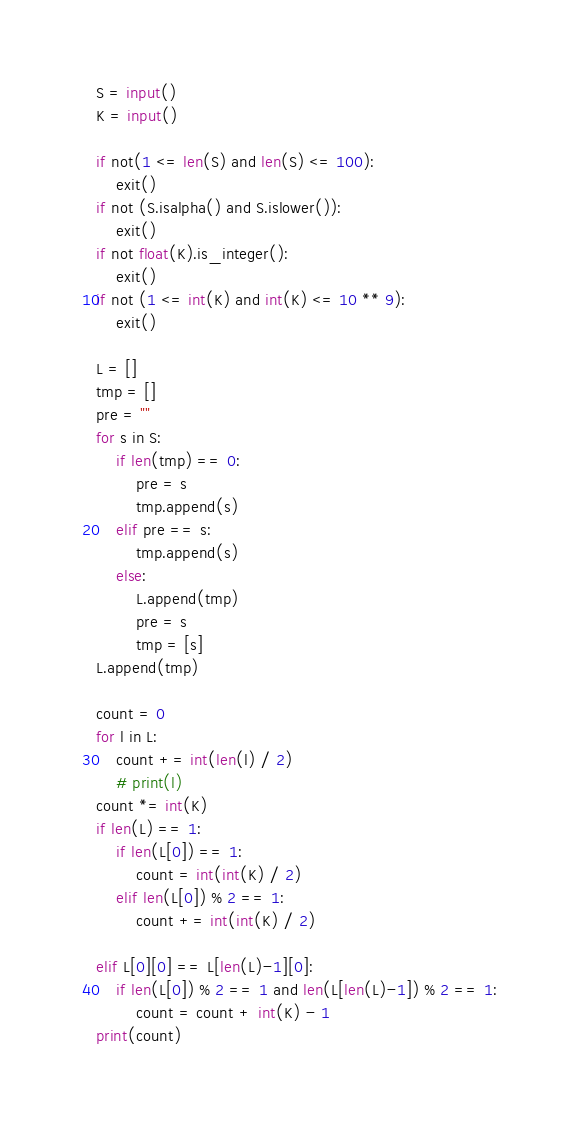<code> <loc_0><loc_0><loc_500><loc_500><_Python_>S = input()
K = input()

if not(1 <= len(S) and len(S) <= 100):
    exit()
if not (S.isalpha() and S.islower()):
    exit()
if not float(K).is_integer():
    exit()
if not (1 <= int(K) and int(K) <= 10 ** 9):
    exit()

L = []
tmp = []
pre = ""
for s in S:
    if len(tmp) == 0:
        pre = s
        tmp.append(s)
    elif pre == s:
        tmp.append(s)
    else:
        L.append(tmp)
        pre = s
        tmp = [s]
L.append(tmp)

count = 0
for l in L:
    count += int(len(l) / 2)
    # print(l)
count *= int(K)
if len(L) == 1:
    if len(L[0]) == 1:
        count = int(int(K) / 2)
    elif len(L[0]) % 2 == 1:
        count += int(int(K) / 2)
    
elif L[0][0] == L[len(L)-1][0]:
    if len(L[0]) % 2 == 1 and len(L[len(L)-1]) % 2 == 1:
        count = count + int(K) - 1
print(count)
</code> 